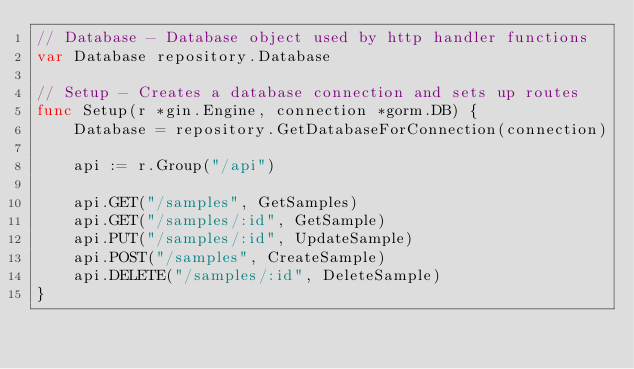<code> <loc_0><loc_0><loc_500><loc_500><_Go_>// Database - Database object used by http handler functions
var Database repository.Database

// Setup - Creates a database connection and sets up routes
func Setup(r *gin.Engine, connection *gorm.DB) {
	Database = repository.GetDatabaseForConnection(connection)

	api := r.Group("/api")

	api.GET("/samples", GetSamples)
	api.GET("/samples/:id", GetSample)
	api.PUT("/samples/:id", UpdateSample)
	api.POST("/samples", CreateSample)
	api.DELETE("/samples/:id", DeleteSample)
}
</code> 